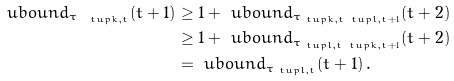Convert formula to latex. <formula><loc_0><loc_0><loc_500><loc_500>\ u b o u n d _ { \tau _ { \ t u p { k , t } } } ( t + 1 ) & \geq 1 + \ u b o u n d _ { \tau _ { \ t u p { k , t } \ t u p { l , t + 1 } } } ( t + 2 ) \\ & \geq 1 + \ u b o u n d _ { \tau _ { \ t u p { l , t } \ t u p { k , t + 1 } } } ( t + 2 ) \\ & = \ u b o u n d _ { \tau _ { \ t u p { l , t } } } ( t + 1 ) \, .</formula> 